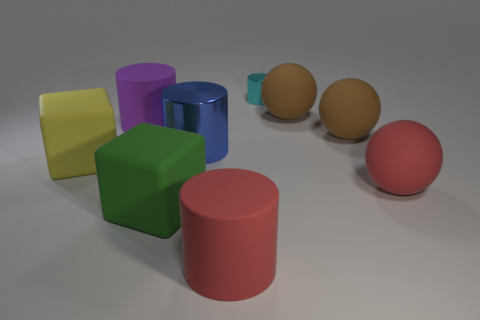Subtract all big cylinders. How many cylinders are left? 1 Add 1 cyan shiny objects. How many objects exist? 10 Subtract 2 blocks. How many blocks are left? 0 Subtract all blocks. How many objects are left? 7 Subtract all red spheres. How many spheres are left? 2 Subtract 1 cyan cylinders. How many objects are left? 8 Subtract all gray cylinders. Subtract all cyan blocks. How many cylinders are left? 4 Subtract all red balls. How many cyan cylinders are left? 1 Subtract all matte cylinders. Subtract all large purple things. How many objects are left? 6 Add 1 big purple cylinders. How many big purple cylinders are left? 2 